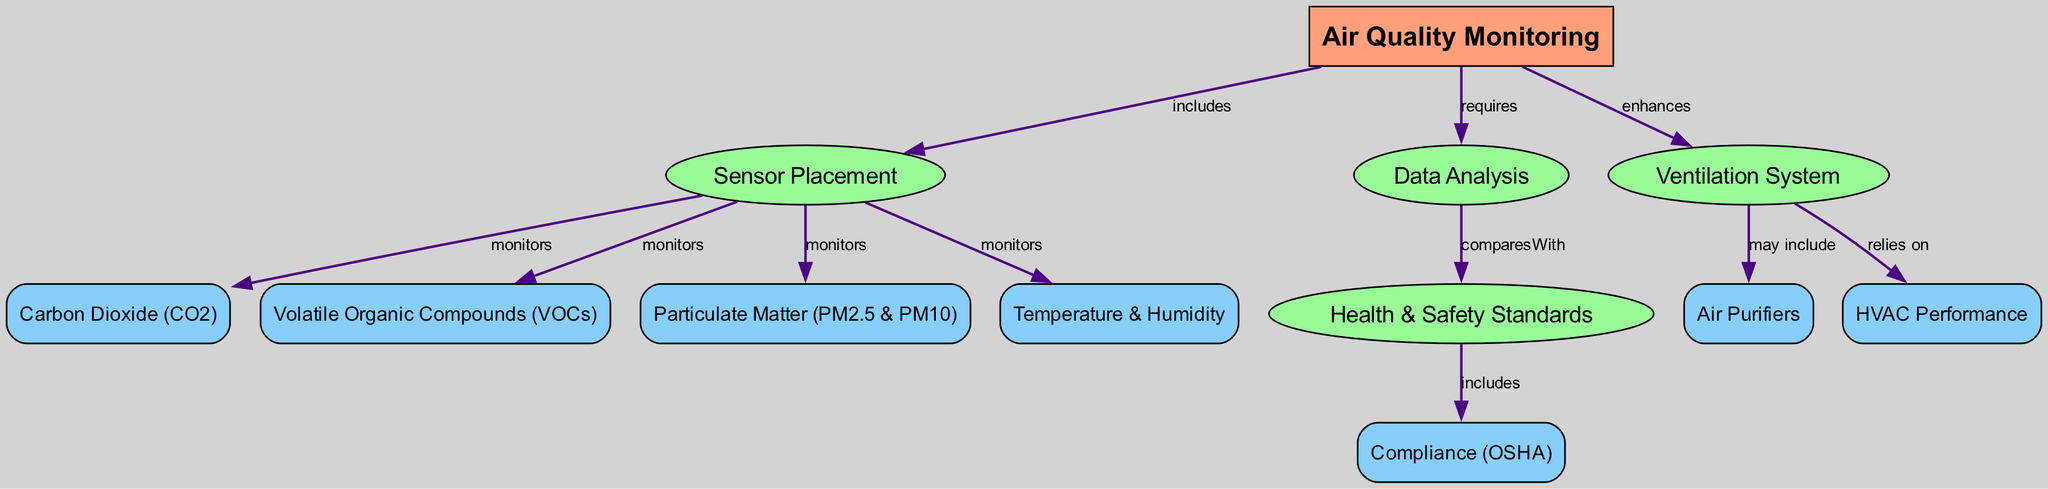What is the main topic of the diagram? The main topic is represented by the first node, which is "Air Quality Monitoring". It is labeled to indicate its primary focus in the diagram.
Answer: Air Quality Monitoring How many components are monitored under sensor placement? There are four components mentioned in the diagram that are monitored under "Sensor Placement": Carbon Dioxide, Volatile Organic Compounds, Particulate Matter, and Temperature & Humidity. This can be counted directly from the edges leading from "Sensor Placement".
Answer: 4 Which component is related to health and safety standards? The component related to health and safety standards is "Compliance (OSHA)". This connection can be identified through the flow from "Health & Safety Standards" to "Compliance (OSHA)".
Answer: Compliance (OSHA) What may be included in the ventilation system? The diagram indicates that "Air Purifiers" may be included in the "Ventilation System". This is established by the direct relationship shown between these two nodes.
Answer: Air Purifiers What is required for air quality monitoring? "Data Analysis" is required for air quality monitoring as indicated in the edges that connect these two topics directly.
Answer: Data Analysis How does ventilation enhance air quality monitoring? Ventilation enhances air quality monitoring by providing a system through which the air is circulated and exchanged, potentially improving overall air quality. This relationship is implied through the connection labeled "enhances".
Answer: Enhances What do the air quality monitoring components compare with? The air quality monitoring components compare with "Health & Safety Standards" as indicated by the edge that shows this relationship in the diagram.
Answer: Health & Safety Standards What does the ventilation system rely on? The Ventilation System relies on "HVAC Performance". This connection can be traced directly through the edges in the diagram that link "Ventilation" to "HVAC Performance".
Answer: HVAC Performance 